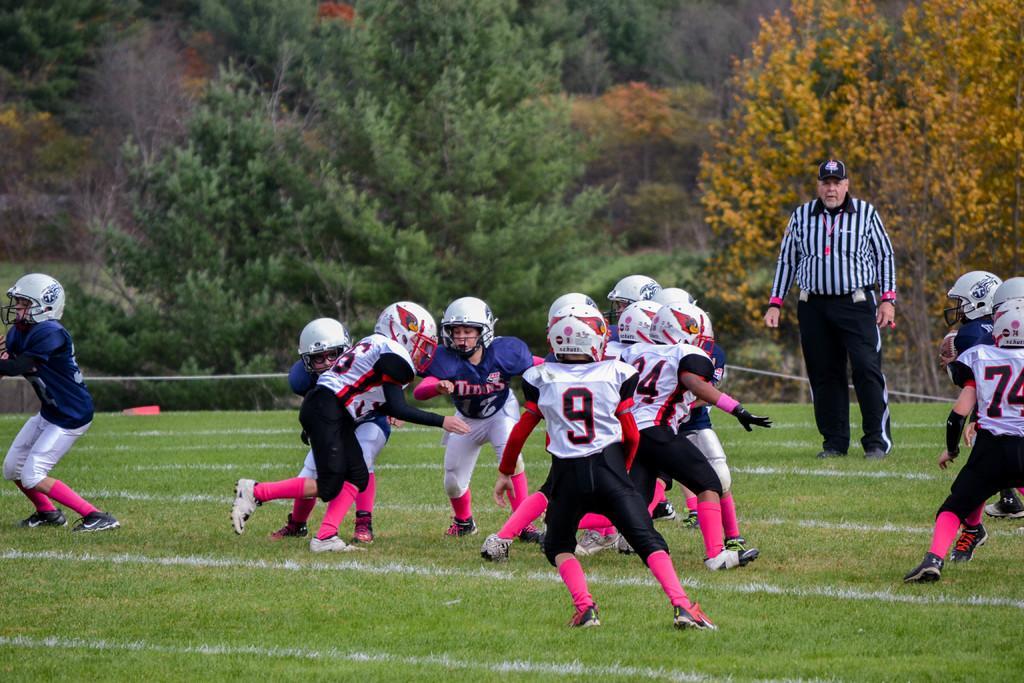In one or two sentences, can you explain what this image depicts? In this image we can see people playing on the ground. In the background there is a referee and trees. 